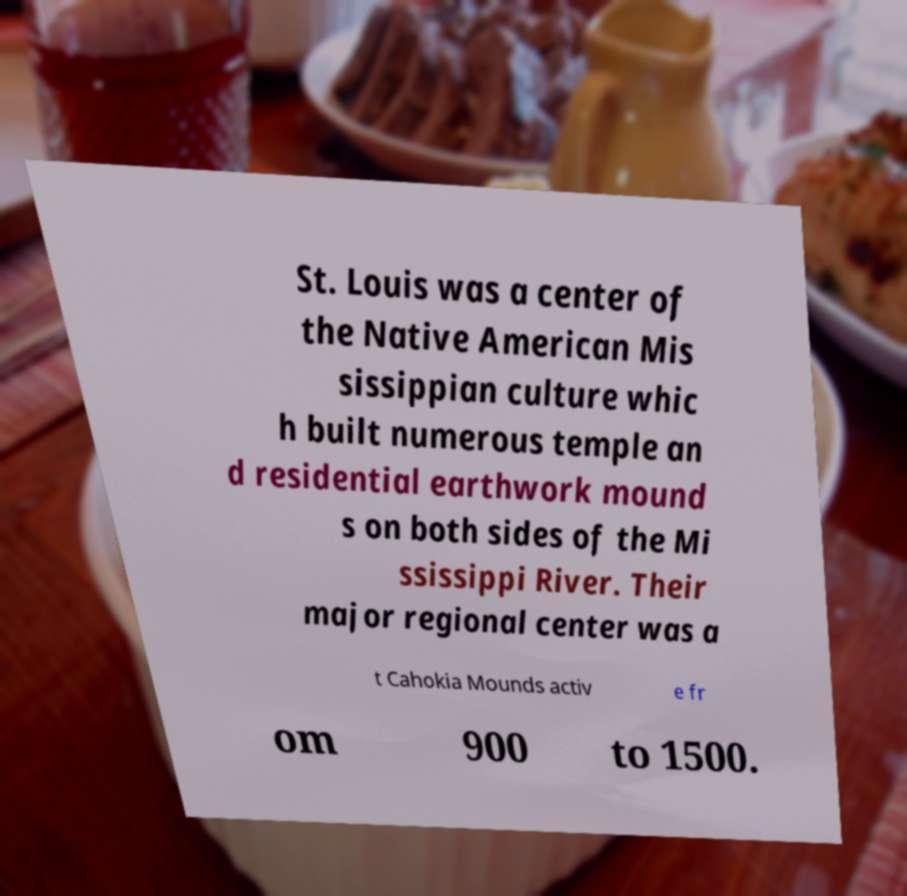There's text embedded in this image that I need extracted. Can you transcribe it verbatim? St. Louis was a center of the Native American Mis sissippian culture whic h built numerous temple an d residential earthwork mound s on both sides of the Mi ssissippi River. Their major regional center was a t Cahokia Mounds activ e fr om 900 to 1500. 